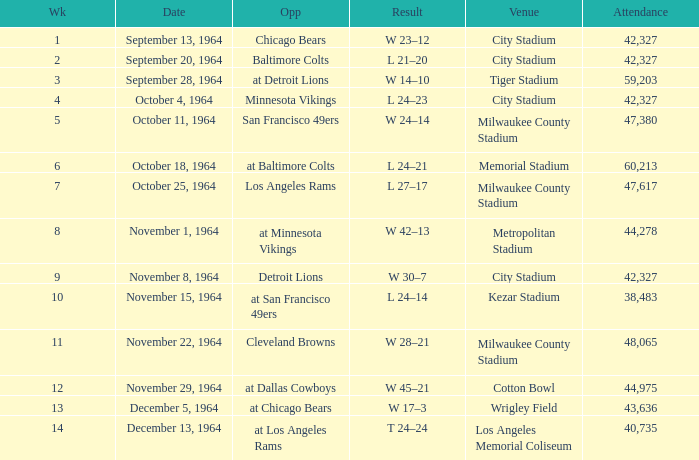What is the average attendance at a week 4 game? 42327.0. 